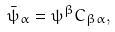Convert formula to latex. <formula><loc_0><loc_0><loc_500><loc_500>\bar { \psi } _ { \alpha } = \psi ^ { \beta } C _ { \beta \alpha } ,</formula> 